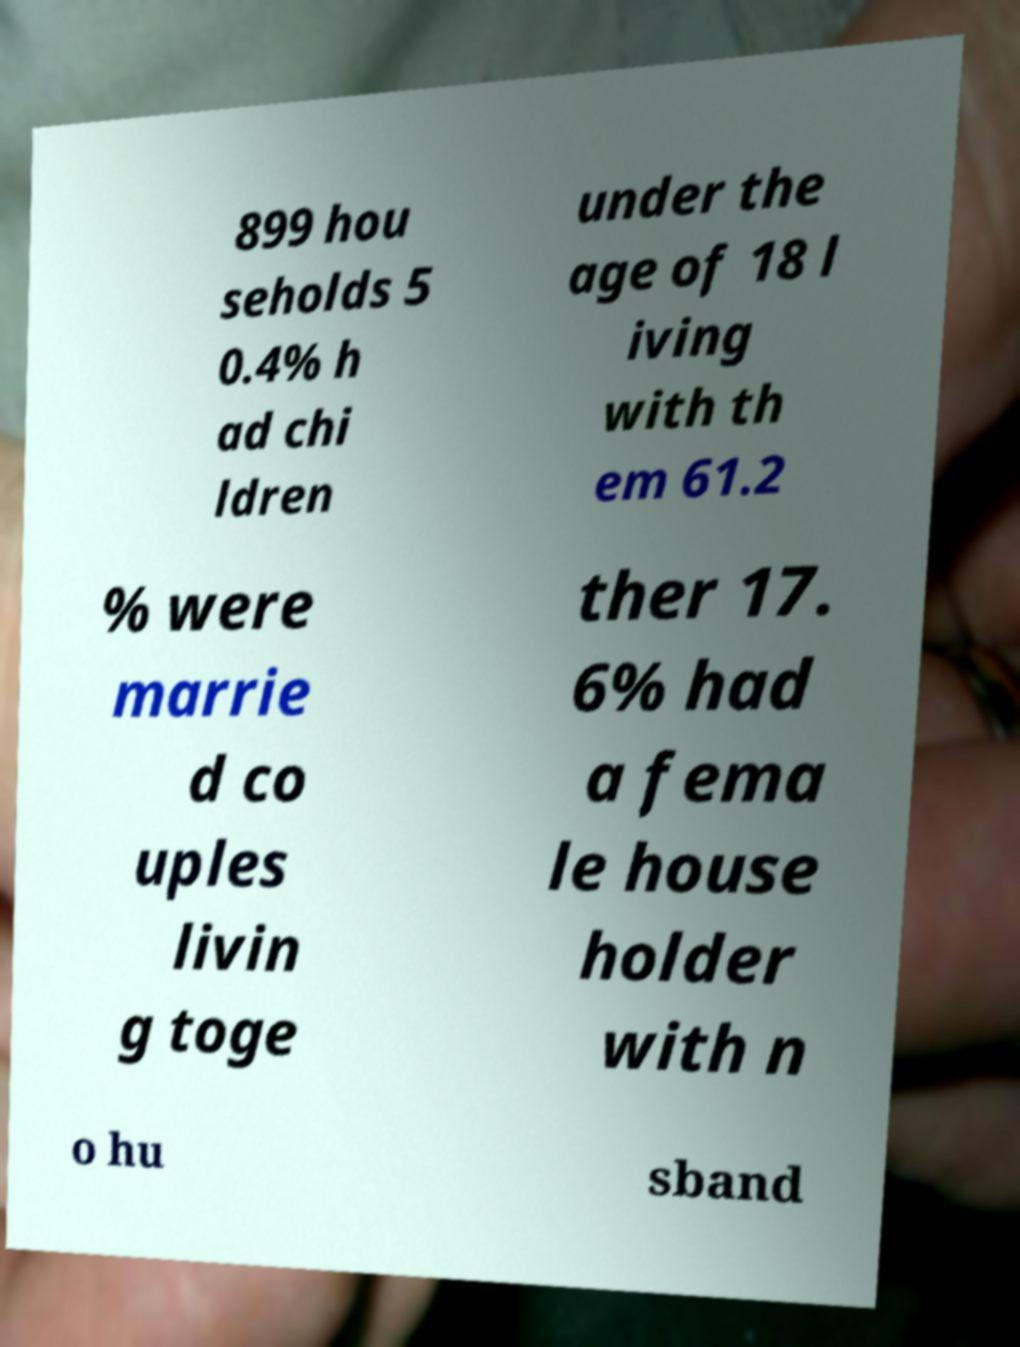Please identify and transcribe the text found in this image. 899 hou seholds 5 0.4% h ad chi ldren under the age of 18 l iving with th em 61.2 % were marrie d co uples livin g toge ther 17. 6% had a fema le house holder with n o hu sband 